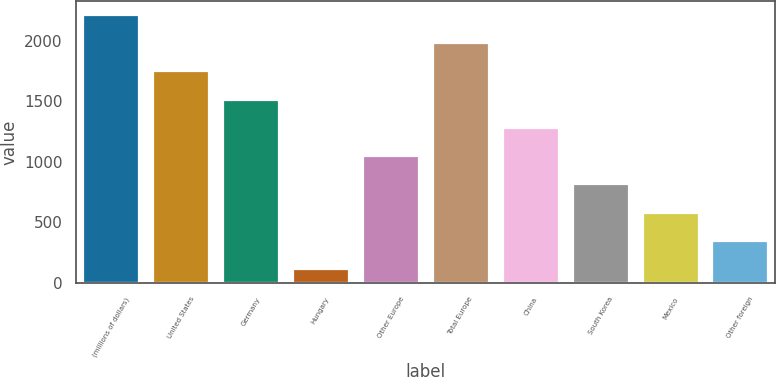Convert chart to OTSL. <chart><loc_0><loc_0><loc_500><loc_500><bar_chart><fcel>(millions of dollars)<fcel>United States<fcel>Germany<fcel>Hungary<fcel>Other Europe<fcel>Total Europe<fcel>China<fcel>South Korea<fcel>Mexico<fcel>Other foreign<nl><fcel>2214.53<fcel>1747.39<fcel>1513.82<fcel>112.4<fcel>1046.68<fcel>1980.96<fcel>1280.25<fcel>813.11<fcel>579.54<fcel>345.97<nl></chart> 